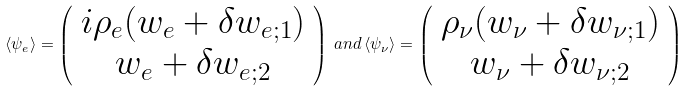<formula> <loc_0><loc_0><loc_500><loc_500>\langle \psi _ { e } \rangle = \left ( \begin{array} { c } i \rho _ { e } ( w _ { e } + \delta w _ { e ; 1 } ) \\ w _ { e } + \delta w _ { e ; 2 } \end{array} \right ) \, a n d \, \langle \psi _ { \nu } \rangle = \left ( \begin{array} { c } \rho _ { \nu } ( w _ { \nu } + \delta w _ { \nu ; 1 } ) \\ w _ { \nu } + \delta w _ { \nu ; 2 } \end{array} \right )</formula> 